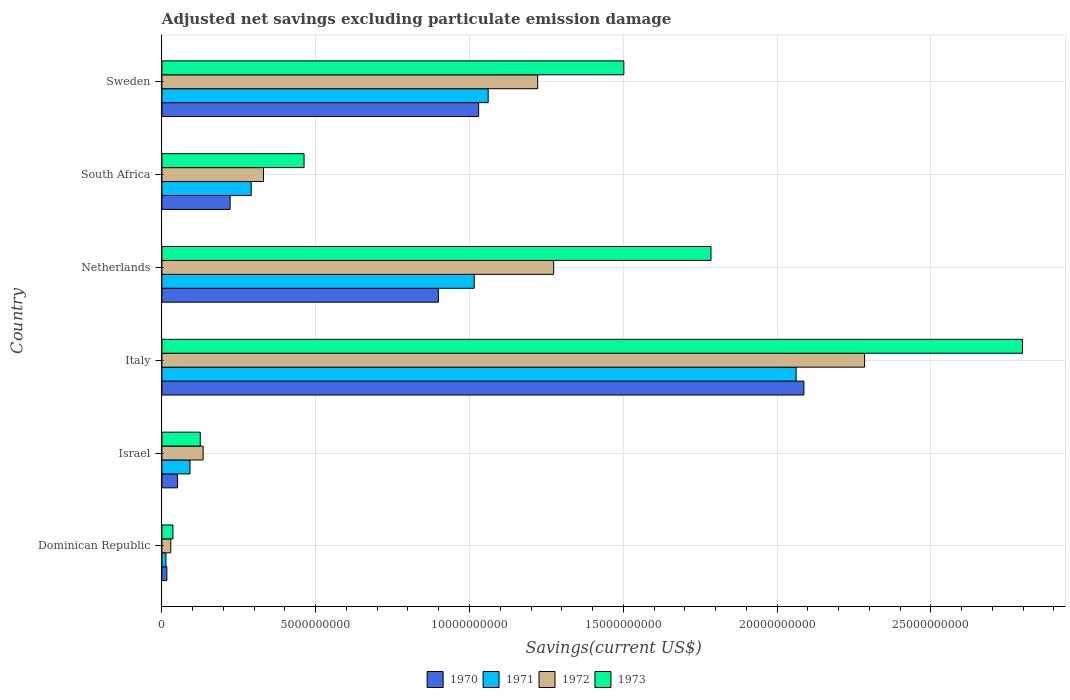Are the number of bars per tick equal to the number of legend labels?
Make the answer very short. Yes. What is the label of the 5th group of bars from the top?
Offer a terse response. Israel. What is the adjusted net savings in 1971 in Italy?
Provide a short and direct response. 2.06e+1. Across all countries, what is the maximum adjusted net savings in 1971?
Make the answer very short. 2.06e+1. Across all countries, what is the minimum adjusted net savings in 1973?
Make the answer very short. 3.58e+08. In which country was the adjusted net savings in 1973 maximum?
Give a very brief answer. Italy. In which country was the adjusted net savings in 1970 minimum?
Make the answer very short. Dominican Republic. What is the total adjusted net savings in 1973 in the graph?
Your response must be concise. 6.71e+1. What is the difference between the adjusted net savings in 1971 in Italy and that in South Africa?
Ensure brevity in your answer.  1.77e+1. What is the difference between the adjusted net savings in 1970 in Italy and the adjusted net savings in 1973 in Israel?
Keep it short and to the point. 1.96e+1. What is the average adjusted net savings in 1970 per country?
Offer a very short reply. 7.17e+09. What is the difference between the adjusted net savings in 1972 and adjusted net savings in 1971 in Sweden?
Ensure brevity in your answer.  1.61e+09. In how many countries, is the adjusted net savings in 1970 greater than 14000000000 US$?
Your answer should be very brief. 1. What is the ratio of the adjusted net savings in 1971 in Netherlands to that in Sweden?
Provide a succinct answer. 0.96. Is the difference between the adjusted net savings in 1972 in Dominican Republic and Israel greater than the difference between the adjusted net savings in 1971 in Dominican Republic and Israel?
Your answer should be very brief. No. What is the difference between the highest and the second highest adjusted net savings in 1970?
Offer a very short reply. 1.06e+1. What is the difference between the highest and the lowest adjusted net savings in 1970?
Keep it short and to the point. 2.07e+1. What does the 2nd bar from the bottom in Israel represents?
Keep it short and to the point. 1971. What is the difference between two consecutive major ticks on the X-axis?
Offer a very short reply. 5.00e+09. Where does the legend appear in the graph?
Offer a very short reply. Bottom center. How many legend labels are there?
Provide a short and direct response. 4. What is the title of the graph?
Offer a terse response. Adjusted net savings excluding particulate emission damage. What is the label or title of the X-axis?
Provide a short and direct response. Savings(current US$). What is the Savings(current US$) of 1970 in Dominican Republic?
Keep it short and to the point. 1.61e+08. What is the Savings(current US$) in 1971 in Dominican Republic?
Ensure brevity in your answer.  1.32e+08. What is the Savings(current US$) in 1972 in Dominican Republic?
Your response must be concise. 2.89e+08. What is the Savings(current US$) of 1973 in Dominican Republic?
Offer a very short reply. 3.58e+08. What is the Savings(current US$) in 1970 in Israel?
Your response must be concise. 5.08e+08. What is the Savings(current US$) of 1971 in Israel?
Provide a succinct answer. 9.14e+08. What is the Savings(current US$) in 1972 in Israel?
Your answer should be compact. 1.34e+09. What is the Savings(current US$) of 1973 in Israel?
Give a very brief answer. 1.25e+09. What is the Savings(current US$) in 1970 in Italy?
Offer a terse response. 2.09e+1. What is the Savings(current US$) of 1971 in Italy?
Keep it short and to the point. 2.06e+1. What is the Savings(current US$) of 1972 in Italy?
Provide a short and direct response. 2.28e+1. What is the Savings(current US$) in 1973 in Italy?
Provide a succinct answer. 2.80e+1. What is the Savings(current US$) of 1970 in Netherlands?
Provide a succinct answer. 8.99e+09. What is the Savings(current US$) of 1971 in Netherlands?
Offer a terse response. 1.02e+1. What is the Savings(current US$) in 1972 in Netherlands?
Provide a short and direct response. 1.27e+1. What is the Savings(current US$) in 1973 in Netherlands?
Ensure brevity in your answer.  1.79e+1. What is the Savings(current US$) in 1970 in South Africa?
Give a very brief answer. 2.22e+09. What is the Savings(current US$) of 1971 in South Africa?
Keep it short and to the point. 2.90e+09. What is the Savings(current US$) in 1972 in South Africa?
Offer a terse response. 3.30e+09. What is the Savings(current US$) of 1973 in South Africa?
Ensure brevity in your answer.  4.62e+09. What is the Savings(current US$) in 1970 in Sweden?
Make the answer very short. 1.03e+1. What is the Savings(current US$) in 1971 in Sweden?
Give a very brief answer. 1.06e+1. What is the Savings(current US$) in 1972 in Sweden?
Ensure brevity in your answer.  1.22e+1. What is the Savings(current US$) in 1973 in Sweden?
Your answer should be compact. 1.50e+1. Across all countries, what is the maximum Savings(current US$) in 1970?
Offer a very short reply. 2.09e+1. Across all countries, what is the maximum Savings(current US$) of 1971?
Make the answer very short. 2.06e+1. Across all countries, what is the maximum Savings(current US$) in 1972?
Your response must be concise. 2.28e+1. Across all countries, what is the maximum Savings(current US$) of 1973?
Keep it short and to the point. 2.80e+1. Across all countries, what is the minimum Savings(current US$) in 1970?
Your response must be concise. 1.61e+08. Across all countries, what is the minimum Savings(current US$) of 1971?
Provide a short and direct response. 1.32e+08. Across all countries, what is the minimum Savings(current US$) in 1972?
Make the answer very short. 2.89e+08. Across all countries, what is the minimum Savings(current US$) in 1973?
Your response must be concise. 3.58e+08. What is the total Savings(current US$) in 1970 in the graph?
Your response must be concise. 4.30e+1. What is the total Savings(current US$) in 1971 in the graph?
Your answer should be compact. 4.53e+1. What is the total Savings(current US$) of 1972 in the graph?
Your answer should be compact. 5.27e+1. What is the total Savings(current US$) in 1973 in the graph?
Provide a short and direct response. 6.71e+1. What is the difference between the Savings(current US$) of 1970 in Dominican Republic and that in Israel?
Offer a very short reply. -3.47e+08. What is the difference between the Savings(current US$) in 1971 in Dominican Republic and that in Israel?
Your response must be concise. -7.83e+08. What is the difference between the Savings(current US$) of 1972 in Dominican Republic and that in Israel?
Offer a terse response. -1.05e+09. What is the difference between the Savings(current US$) in 1973 in Dominican Republic and that in Israel?
Keep it short and to the point. -8.89e+08. What is the difference between the Savings(current US$) in 1970 in Dominican Republic and that in Italy?
Your response must be concise. -2.07e+1. What is the difference between the Savings(current US$) in 1971 in Dominican Republic and that in Italy?
Your response must be concise. -2.05e+1. What is the difference between the Savings(current US$) of 1972 in Dominican Republic and that in Italy?
Ensure brevity in your answer.  -2.26e+1. What is the difference between the Savings(current US$) in 1973 in Dominican Republic and that in Italy?
Make the answer very short. -2.76e+1. What is the difference between the Savings(current US$) of 1970 in Dominican Republic and that in Netherlands?
Make the answer very short. -8.83e+09. What is the difference between the Savings(current US$) in 1971 in Dominican Republic and that in Netherlands?
Ensure brevity in your answer.  -1.00e+1. What is the difference between the Savings(current US$) of 1972 in Dominican Republic and that in Netherlands?
Your response must be concise. -1.24e+1. What is the difference between the Savings(current US$) of 1973 in Dominican Republic and that in Netherlands?
Ensure brevity in your answer.  -1.75e+1. What is the difference between the Savings(current US$) of 1970 in Dominican Republic and that in South Africa?
Offer a terse response. -2.06e+09. What is the difference between the Savings(current US$) of 1971 in Dominican Republic and that in South Africa?
Provide a short and direct response. -2.77e+09. What is the difference between the Savings(current US$) of 1972 in Dominican Republic and that in South Africa?
Provide a succinct answer. -3.01e+09. What is the difference between the Savings(current US$) in 1973 in Dominican Republic and that in South Africa?
Your response must be concise. -4.26e+09. What is the difference between the Savings(current US$) in 1970 in Dominican Republic and that in Sweden?
Make the answer very short. -1.01e+1. What is the difference between the Savings(current US$) of 1971 in Dominican Republic and that in Sweden?
Provide a succinct answer. -1.05e+1. What is the difference between the Savings(current US$) of 1972 in Dominican Republic and that in Sweden?
Provide a succinct answer. -1.19e+1. What is the difference between the Savings(current US$) of 1973 in Dominican Republic and that in Sweden?
Ensure brevity in your answer.  -1.47e+1. What is the difference between the Savings(current US$) in 1970 in Israel and that in Italy?
Your answer should be very brief. -2.04e+1. What is the difference between the Savings(current US$) of 1971 in Israel and that in Italy?
Offer a very short reply. -1.97e+1. What is the difference between the Savings(current US$) in 1972 in Israel and that in Italy?
Offer a terse response. -2.15e+1. What is the difference between the Savings(current US$) of 1973 in Israel and that in Italy?
Your answer should be compact. -2.67e+1. What is the difference between the Savings(current US$) of 1970 in Israel and that in Netherlands?
Give a very brief answer. -8.48e+09. What is the difference between the Savings(current US$) in 1971 in Israel and that in Netherlands?
Make the answer very short. -9.24e+09. What is the difference between the Savings(current US$) in 1972 in Israel and that in Netherlands?
Your response must be concise. -1.14e+1. What is the difference between the Savings(current US$) in 1973 in Israel and that in Netherlands?
Your answer should be very brief. -1.66e+1. What is the difference between the Savings(current US$) in 1970 in Israel and that in South Africa?
Keep it short and to the point. -1.71e+09. What is the difference between the Savings(current US$) of 1971 in Israel and that in South Africa?
Make the answer very short. -1.99e+09. What is the difference between the Savings(current US$) of 1972 in Israel and that in South Africa?
Keep it short and to the point. -1.96e+09. What is the difference between the Savings(current US$) in 1973 in Israel and that in South Africa?
Ensure brevity in your answer.  -3.38e+09. What is the difference between the Savings(current US$) in 1970 in Israel and that in Sweden?
Your response must be concise. -9.79e+09. What is the difference between the Savings(current US$) of 1971 in Israel and that in Sweden?
Make the answer very short. -9.69e+09. What is the difference between the Savings(current US$) of 1972 in Israel and that in Sweden?
Provide a succinct answer. -1.09e+1. What is the difference between the Savings(current US$) in 1973 in Israel and that in Sweden?
Your response must be concise. -1.38e+1. What is the difference between the Savings(current US$) of 1970 in Italy and that in Netherlands?
Provide a succinct answer. 1.19e+1. What is the difference between the Savings(current US$) in 1971 in Italy and that in Netherlands?
Ensure brevity in your answer.  1.05e+1. What is the difference between the Savings(current US$) of 1972 in Italy and that in Netherlands?
Provide a succinct answer. 1.01e+1. What is the difference between the Savings(current US$) of 1973 in Italy and that in Netherlands?
Make the answer very short. 1.01e+1. What is the difference between the Savings(current US$) of 1970 in Italy and that in South Africa?
Give a very brief answer. 1.87e+1. What is the difference between the Savings(current US$) in 1971 in Italy and that in South Africa?
Offer a terse response. 1.77e+1. What is the difference between the Savings(current US$) in 1972 in Italy and that in South Africa?
Your answer should be very brief. 1.95e+1. What is the difference between the Savings(current US$) in 1973 in Italy and that in South Africa?
Make the answer very short. 2.34e+1. What is the difference between the Savings(current US$) of 1970 in Italy and that in Sweden?
Ensure brevity in your answer.  1.06e+1. What is the difference between the Savings(current US$) in 1971 in Italy and that in Sweden?
Provide a succinct answer. 1.00e+1. What is the difference between the Savings(current US$) in 1972 in Italy and that in Sweden?
Ensure brevity in your answer.  1.06e+1. What is the difference between the Savings(current US$) in 1973 in Italy and that in Sweden?
Provide a short and direct response. 1.30e+1. What is the difference between the Savings(current US$) in 1970 in Netherlands and that in South Africa?
Make the answer very short. 6.77e+09. What is the difference between the Savings(current US$) in 1971 in Netherlands and that in South Africa?
Your response must be concise. 7.25e+09. What is the difference between the Savings(current US$) in 1972 in Netherlands and that in South Africa?
Make the answer very short. 9.43e+09. What is the difference between the Savings(current US$) of 1973 in Netherlands and that in South Africa?
Your answer should be compact. 1.32e+1. What is the difference between the Savings(current US$) of 1970 in Netherlands and that in Sweden?
Your answer should be very brief. -1.31e+09. What is the difference between the Savings(current US$) of 1971 in Netherlands and that in Sweden?
Ensure brevity in your answer.  -4.54e+08. What is the difference between the Savings(current US$) in 1972 in Netherlands and that in Sweden?
Keep it short and to the point. 5.20e+08. What is the difference between the Savings(current US$) in 1973 in Netherlands and that in Sweden?
Keep it short and to the point. 2.83e+09. What is the difference between the Savings(current US$) of 1970 in South Africa and that in Sweden?
Your answer should be very brief. -8.08e+09. What is the difference between the Savings(current US$) of 1971 in South Africa and that in Sweden?
Offer a very short reply. -7.70e+09. What is the difference between the Savings(current US$) of 1972 in South Africa and that in Sweden?
Your answer should be compact. -8.91e+09. What is the difference between the Savings(current US$) in 1973 in South Africa and that in Sweden?
Offer a terse response. -1.04e+1. What is the difference between the Savings(current US$) in 1970 in Dominican Republic and the Savings(current US$) in 1971 in Israel?
Provide a succinct answer. -7.53e+08. What is the difference between the Savings(current US$) of 1970 in Dominican Republic and the Savings(current US$) of 1972 in Israel?
Your answer should be very brief. -1.18e+09. What is the difference between the Savings(current US$) in 1970 in Dominican Republic and the Savings(current US$) in 1973 in Israel?
Keep it short and to the point. -1.09e+09. What is the difference between the Savings(current US$) in 1971 in Dominican Republic and the Savings(current US$) in 1972 in Israel?
Provide a short and direct response. -1.21e+09. What is the difference between the Savings(current US$) of 1971 in Dominican Republic and the Savings(current US$) of 1973 in Israel?
Give a very brief answer. -1.12e+09. What is the difference between the Savings(current US$) of 1972 in Dominican Republic and the Savings(current US$) of 1973 in Israel?
Give a very brief answer. -9.58e+08. What is the difference between the Savings(current US$) of 1970 in Dominican Republic and the Savings(current US$) of 1971 in Italy?
Provide a succinct answer. -2.05e+1. What is the difference between the Savings(current US$) in 1970 in Dominican Republic and the Savings(current US$) in 1972 in Italy?
Your response must be concise. -2.27e+1. What is the difference between the Savings(current US$) of 1970 in Dominican Republic and the Savings(current US$) of 1973 in Italy?
Offer a very short reply. -2.78e+1. What is the difference between the Savings(current US$) in 1971 in Dominican Republic and the Savings(current US$) in 1972 in Italy?
Offer a terse response. -2.27e+1. What is the difference between the Savings(current US$) of 1971 in Dominican Republic and the Savings(current US$) of 1973 in Italy?
Keep it short and to the point. -2.78e+1. What is the difference between the Savings(current US$) of 1972 in Dominican Republic and the Savings(current US$) of 1973 in Italy?
Offer a terse response. -2.77e+1. What is the difference between the Savings(current US$) of 1970 in Dominican Republic and the Savings(current US$) of 1971 in Netherlands?
Offer a terse response. -9.99e+09. What is the difference between the Savings(current US$) of 1970 in Dominican Republic and the Savings(current US$) of 1972 in Netherlands?
Provide a short and direct response. -1.26e+1. What is the difference between the Savings(current US$) in 1970 in Dominican Republic and the Savings(current US$) in 1973 in Netherlands?
Make the answer very short. -1.77e+1. What is the difference between the Savings(current US$) in 1971 in Dominican Republic and the Savings(current US$) in 1972 in Netherlands?
Give a very brief answer. -1.26e+1. What is the difference between the Savings(current US$) in 1971 in Dominican Republic and the Savings(current US$) in 1973 in Netherlands?
Your answer should be compact. -1.77e+1. What is the difference between the Savings(current US$) in 1972 in Dominican Republic and the Savings(current US$) in 1973 in Netherlands?
Keep it short and to the point. -1.76e+1. What is the difference between the Savings(current US$) in 1970 in Dominican Republic and the Savings(current US$) in 1971 in South Africa?
Offer a very short reply. -2.74e+09. What is the difference between the Savings(current US$) of 1970 in Dominican Republic and the Savings(current US$) of 1972 in South Africa?
Provide a short and direct response. -3.14e+09. What is the difference between the Savings(current US$) of 1970 in Dominican Republic and the Savings(current US$) of 1973 in South Africa?
Keep it short and to the point. -4.46e+09. What is the difference between the Savings(current US$) of 1971 in Dominican Republic and the Savings(current US$) of 1972 in South Africa?
Ensure brevity in your answer.  -3.17e+09. What is the difference between the Savings(current US$) of 1971 in Dominican Republic and the Savings(current US$) of 1973 in South Africa?
Provide a succinct answer. -4.49e+09. What is the difference between the Savings(current US$) of 1972 in Dominican Republic and the Savings(current US$) of 1973 in South Africa?
Offer a terse response. -4.33e+09. What is the difference between the Savings(current US$) in 1970 in Dominican Republic and the Savings(current US$) in 1971 in Sweden?
Ensure brevity in your answer.  -1.04e+1. What is the difference between the Savings(current US$) of 1970 in Dominican Republic and the Savings(current US$) of 1972 in Sweden?
Provide a short and direct response. -1.21e+1. What is the difference between the Savings(current US$) of 1970 in Dominican Republic and the Savings(current US$) of 1973 in Sweden?
Your response must be concise. -1.49e+1. What is the difference between the Savings(current US$) of 1971 in Dominican Republic and the Savings(current US$) of 1972 in Sweden?
Make the answer very short. -1.21e+1. What is the difference between the Savings(current US$) in 1971 in Dominican Republic and the Savings(current US$) in 1973 in Sweden?
Offer a terse response. -1.49e+1. What is the difference between the Savings(current US$) in 1972 in Dominican Republic and the Savings(current US$) in 1973 in Sweden?
Ensure brevity in your answer.  -1.47e+1. What is the difference between the Savings(current US$) in 1970 in Israel and the Savings(current US$) in 1971 in Italy?
Make the answer very short. -2.01e+1. What is the difference between the Savings(current US$) of 1970 in Israel and the Savings(current US$) of 1972 in Italy?
Ensure brevity in your answer.  -2.23e+1. What is the difference between the Savings(current US$) in 1970 in Israel and the Savings(current US$) in 1973 in Italy?
Your answer should be compact. -2.75e+1. What is the difference between the Savings(current US$) of 1971 in Israel and the Savings(current US$) of 1972 in Italy?
Offer a very short reply. -2.19e+1. What is the difference between the Savings(current US$) of 1971 in Israel and the Savings(current US$) of 1973 in Italy?
Provide a short and direct response. -2.71e+1. What is the difference between the Savings(current US$) of 1972 in Israel and the Savings(current US$) of 1973 in Italy?
Give a very brief answer. -2.66e+1. What is the difference between the Savings(current US$) of 1970 in Israel and the Savings(current US$) of 1971 in Netherlands?
Your answer should be very brief. -9.65e+09. What is the difference between the Savings(current US$) of 1970 in Israel and the Savings(current US$) of 1972 in Netherlands?
Offer a terse response. -1.22e+1. What is the difference between the Savings(current US$) in 1970 in Israel and the Savings(current US$) in 1973 in Netherlands?
Keep it short and to the point. -1.73e+1. What is the difference between the Savings(current US$) in 1971 in Israel and the Savings(current US$) in 1972 in Netherlands?
Your response must be concise. -1.18e+1. What is the difference between the Savings(current US$) in 1971 in Israel and the Savings(current US$) in 1973 in Netherlands?
Offer a terse response. -1.69e+1. What is the difference between the Savings(current US$) of 1972 in Israel and the Savings(current US$) of 1973 in Netherlands?
Your answer should be compact. -1.65e+1. What is the difference between the Savings(current US$) in 1970 in Israel and the Savings(current US$) in 1971 in South Africa?
Your answer should be very brief. -2.39e+09. What is the difference between the Savings(current US$) of 1970 in Israel and the Savings(current US$) of 1972 in South Africa?
Your answer should be compact. -2.79e+09. What is the difference between the Savings(current US$) in 1970 in Israel and the Savings(current US$) in 1973 in South Africa?
Provide a succinct answer. -4.11e+09. What is the difference between the Savings(current US$) in 1971 in Israel and the Savings(current US$) in 1972 in South Africa?
Make the answer very short. -2.39e+09. What is the difference between the Savings(current US$) of 1971 in Israel and the Savings(current US$) of 1973 in South Africa?
Your answer should be very brief. -3.71e+09. What is the difference between the Savings(current US$) of 1972 in Israel and the Savings(current US$) of 1973 in South Africa?
Give a very brief answer. -3.28e+09. What is the difference between the Savings(current US$) in 1970 in Israel and the Savings(current US$) in 1971 in Sweden?
Keep it short and to the point. -1.01e+1. What is the difference between the Savings(current US$) in 1970 in Israel and the Savings(current US$) in 1972 in Sweden?
Make the answer very short. -1.17e+1. What is the difference between the Savings(current US$) of 1970 in Israel and the Savings(current US$) of 1973 in Sweden?
Give a very brief answer. -1.45e+1. What is the difference between the Savings(current US$) in 1971 in Israel and the Savings(current US$) in 1972 in Sweden?
Provide a succinct answer. -1.13e+1. What is the difference between the Savings(current US$) of 1971 in Israel and the Savings(current US$) of 1973 in Sweden?
Offer a very short reply. -1.41e+1. What is the difference between the Savings(current US$) in 1972 in Israel and the Savings(current US$) in 1973 in Sweden?
Give a very brief answer. -1.37e+1. What is the difference between the Savings(current US$) of 1970 in Italy and the Savings(current US$) of 1971 in Netherlands?
Offer a terse response. 1.07e+1. What is the difference between the Savings(current US$) in 1970 in Italy and the Savings(current US$) in 1972 in Netherlands?
Provide a short and direct response. 8.14e+09. What is the difference between the Savings(current US$) in 1970 in Italy and the Savings(current US$) in 1973 in Netherlands?
Keep it short and to the point. 3.02e+09. What is the difference between the Savings(current US$) in 1971 in Italy and the Savings(current US$) in 1972 in Netherlands?
Keep it short and to the point. 7.88e+09. What is the difference between the Savings(current US$) of 1971 in Italy and the Savings(current US$) of 1973 in Netherlands?
Your answer should be compact. 2.77e+09. What is the difference between the Savings(current US$) in 1972 in Italy and the Savings(current US$) in 1973 in Netherlands?
Your answer should be compact. 4.99e+09. What is the difference between the Savings(current US$) of 1970 in Italy and the Savings(current US$) of 1971 in South Africa?
Make the answer very short. 1.80e+1. What is the difference between the Savings(current US$) in 1970 in Italy and the Savings(current US$) in 1972 in South Africa?
Give a very brief answer. 1.76e+1. What is the difference between the Savings(current US$) of 1970 in Italy and the Savings(current US$) of 1973 in South Africa?
Offer a very short reply. 1.62e+1. What is the difference between the Savings(current US$) of 1971 in Italy and the Savings(current US$) of 1972 in South Africa?
Your response must be concise. 1.73e+1. What is the difference between the Savings(current US$) in 1971 in Italy and the Savings(current US$) in 1973 in South Africa?
Ensure brevity in your answer.  1.60e+1. What is the difference between the Savings(current US$) of 1972 in Italy and the Savings(current US$) of 1973 in South Africa?
Keep it short and to the point. 1.82e+1. What is the difference between the Savings(current US$) of 1970 in Italy and the Savings(current US$) of 1971 in Sweden?
Your response must be concise. 1.03e+1. What is the difference between the Savings(current US$) of 1970 in Italy and the Savings(current US$) of 1972 in Sweden?
Your response must be concise. 8.66e+09. What is the difference between the Savings(current US$) of 1970 in Italy and the Savings(current US$) of 1973 in Sweden?
Offer a terse response. 5.85e+09. What is the difference between the Savings(current US$) in 1971 in Italy and the Savings(current US$) in 1972 in Sweden?
Provide a short and direct response. 8.40e+09. What is the difference between the Savings(current US$) in 1971 in Italy and the Savings(current US$) in 1973 in Sweden?
Ensure brevity in your answer.  5.60e+09. What is the difference between the Savings(current US$) of 1972 in Italy and the Savings(current US$) of 1973 in Sweden?
Provide a short and direct response. 7.83e+09. What is the difference between the Savings(current US$) in 1970 in Netherlands and the Savings(current US$) in 1971 in South Africa?
Offer a terse response. 6.09e+09. What is the difference between the Savings(current US$) in 1970 in Netherlands and the Savings(current US$) in 1972 in South Africa?
Offer a terse response. 5.69e+09. What is the difference between the Savings(current US$) in 1970 in Netherlands and the Savings(current US$) in 1973 in South Africa?
Your response must be concise. 4.37e+09. What is the difference between the Savings(current US$) in 1971 in Netherlands and the Savings(current US$) in 1972 in South Africa?
Give a very brief answer. 6.85e+09. What is the difference between the Savings(current US$) of 1971 in Netherlands and the Savings(current US$) of 1973 in South Africa?
Offer a very short reply. 5.53e+09. What is the difference between the Savings(current US$) of 1972 in Netherlands and the Savings(current US$) of 1973 in South Africa?
Ensure brevity in your answer.  8.11e+09. What is the difference between the Savings(current US$) in 1970 in Netherlands and the Savings(current US$) in 1971 in Sweden?
Your response must be concise. -1.62e+09. What is the difference between the Savings(current US$) of 1970 in Netherlands and the Savings(current US$) of 1972 in Sweden?
Offer a terse response. -3.23e+09. What is the difference between the Savings(current US$) in 1970 in Netherlands and the Savings(current US$) in 1973 in Sweden?
Your answer should be compact. -6.03e+09. What is the difference between the Savings(current US$) in 1971 in Netherlands and the Savings(current US$) in 1972 in Sweden?
Ensure brevity in your answer.  -2.06e+09. What is the difference between the Savings(current US$) in 1971 in Netherlands and the Savings(current US$) in 1973 in Sweden?
Your answer should be very brief. -4.86e+09. What is the difference between the Savings(current US$) of 1972 in Netherlands and the Savings(current US$) of 1973 in Sweden?
Provide a succinct answer. -2.28e+09. What is the difference between the Savings(current US$) of 1970 in South Africa and the Savings(current US$) of 1971 in Sweden?
Make the answer very short. -8.39e+09. What is the difference between the Savings(current US$) in 1970 in South Africa and the Savings(current US$) in 1972 in Sweden?
Provide a short and direct response. -1.00e+1. What is the difference between the Savings(current US$) in 1970 in South Africa and the Savings(current US$) in 1973 in Sweden?
Keep it short and to the point. -1.28e+1. What is the difference between the Savings(current US$) of 1971 in South Africa and the Savings(current US$) of 1972 in Sweden?
Offer a very short reply. -9.31e+09. What is the difference between the Savings(current US$) of 1971 in South Africa and the Savings(current US$) of 1973 in Sweden?
Your answer should be very brief. -1.21e+1. What is the difference between the Savings(current US$) in 1972 in South Africa and the Savings(current US$) in 1973 in Sweden?
Your response must be concise. -1.17e+1. What is the average Savings(current US$) of 1970 per country?
Provide a short and direct response. 7.17e+09. What is the average Savings(current US$) in 1971 per country?
Ensure brevity in your answer.  7.55e+09. What is the average Savings(current US$) of 1972 per country?
Your answer should be very brief. 8.79e+09. What is the average Savings(current US$) in 1973 per country?
Provide a short and direct response. 1.12e+1. What is the difference between the Savings(current US$) in 1970 and Savings(current US$) in 1971 in Dominican Republic?
Provide a succinct answer. 2.96e+07. What is the difference between the Savings(current US$) of 1970 and Savings(current US$) of 1972 in Dominican Republic?
Provide a succinct answer. -1.28e+08. What is the difference between the Savings(current US$) in 1970 and Savings(current US$) in 1973 in Dominican Republic?
Provide a succinct answer. -1.97e+08. What is the difference between the Savings(current US$) in 1971 and Savings(current US$) in 1972 in Dominican Republic?
Your response must be concise. -1.57e+08. What is the difference between the Savings(current US$) of 1971 and Savings(current US$) of 1973 in Dominican Republic?
Provide a short and direct response. -2.27e+08. What is the difference between the Savings(current US$) of 1972 and Savings(current US$) of 1973 in Dominican Republic?
Keep it short and to the point. -6.95e+07. What is the difference between the Savings(current US$) in 1970 and Savings(current US$) in 1971 in Israel?
Your response must be concise. -4.06e+08. What is the difference between the Savings(current US$) of 1970 and Savings(current US$) of 1972 in Israel?
Provide a succinct answer. -8.33e+08. What is the difference between the Savings(current US$) of 1970 and Savings(current US$) of 1973 in Israel?
Your answer should be compact. -7.39e+08. What is the difference between the Savings(current US$) in 1971 and Savings(current US$) in 1972 in Israel?
Your response must be concise. -4.27e+08. What is the difference between the Savings(current US$) in 1971 and Savings(current US$) in 1973 in Israel?
Provide a succinct answer. -3.33e+08. What is the difference between the Savings(current US$) in 1972 and Savings(current US$) in 1973 in Israel?
Give a very brief answer. 9.40e+07. What is the difference between the Savings(current US$) in 1970 and Savings(current US$) in 1971 in Italy?
Keep it short and to the point. 2.53e+08. What is the difference between the Savings(current US$) of 1970 and Savings(current US$) of 1972 in Italy?
Give a very brief answer. -1.97e+09. What is the difference between the Savings(current US$) in 1970 and Savings(current US$) in 1973 in Italy?
Offer a terse response. -7.11e+09. What is the difference between the Savings(current US$) of 1971 and Savings(current US$) of 1972 in Italy?
Ensure brevity in your answer.  -2.23e+09. What is the difference between the Savings(current US$) in 1971 and Savings(current US$) in 1973 in Italy?
Offer a very short reply. -7.36e+09. What is the difference between the Savings(current US$) of 1972 and Savings(current US$) of 1973 in Italy?
Provide a short and direct response. -5.13e+09. What is the difference between the Savings(current US$) of 1970 and Savings(current US$) of 1971 in Netherlands?
Provide a succinct answer. -1.17e+09. What is the difference between the Savings(current US$) in 1970 and Savings(current US$) in 1972 in Netherlands?
Give a very brief answer. -3.75e+09. What is the difference between the Savings(current US$) in 1970 and Savings(current US$) in 1973 in Netherlands?
Provide a short and direct response. -8.86e+09. What is the difference between the Savings(current US$) in 1971 and Savings(current US$) in 1972 in Netherlands?
Your answer should be very brief. -2.58e+09. What is the difference between the Savings(current US$) of 1971 and Savings(current US$) of 1973 in Netherlands?
Offer a terse response. -7.70e+09. What is the difference between the Savings(current US$) of 1972 and Savings(current US$) of 1973 in Netherlands?
Your response must be concise. -5.11e+09. What is the difference between the Savings(current US$) in 1970 and Savings(current US$) in 1971 in South Africa?
Your answer should be compact. -6.85e+08. What is the difference between the Savings(current US$) in 1970 and Savings(current US$) in 1972 in South Africa?
Keep it short and to the point. -1.08e+09. What is the difference between the Savings(current US$) in 1970 and Savings(current US$) in 1973 in South Africa?
Your response must be concise. -2.40e+09. What is the difference between the Savings(current US$) of 1971 and Savings(current US$) of 1972 in South Africa?
Your response must be concise. -4.00e+08. What is the difference between the Savings(current US$) of 1971 and Savings(current US$) of 1973 in South Africa?
Your response must be concise. -1.72e+09. What is the difference between the Savings(current US$) in 1972 and Savings(current US$) in 1973 in South Africa?
Offer a very short reply. -1.32e+09. What is the difference between the Savings(current US$) in 1970 and Savings(current US$) in 1971 in Sweden?
Ensure brevity in your answer.  -3.10e+08. What is the difference between the Savings(current US$) of 1970 and Savings(current US$) of 1972 in Sweden?
Keep it short and to the point. -1.92e+09. What is the difference between the Savings(current US$) in 1970 and Savings(current US$) in 1973 in Sweden?
Make the answer very short. -4.72e+09. What is the difference between the Savings(current US$) of 1971 and Savings(current US$) of 1972 in Sweden?
Your answer should be compact. -1.61e+09. What is the difference between the Savings(current US$) in 1971 and Savings(current US$) in 1973 in Sweden?
Offer a very short reply. -4.41e+09. What is the difference between the Savings(current US$) in 1972 and Savings(current US$) in 1973 in Sweden?
Your answer should be very brief. -2.80e+09. What is the ratio of the Savings(current US$) of 1970 in Dominican Republic to that in Israel?
Your answer should be compact. 0.32. What is the ratio of the Savings(current US$) of 1971 in Dominican Republic to that in Israel?
Provide a short and direct response. 0.14. What is the ratio of the Savings(current US$) of 1972 in Dominican Republic to that in Israel?
Your answer should be compact. 0.22. What is the ratio of the Savings(current US$) of 1973 in Dominican Republic to that in Israel?
Your answer should be compact. 0.29. What is the ratio of the Savings(current US$) of 1970 in Dominican Republic to that in Italy?
Offer a very short reply. 0.01. What is the ratio of the Savings(current US$) of 1971 in Dominican Republic to that in Italy?
Ensure brevity in your answer.  0.01. What is the ratio of the Savings(current US$) in 1972 in Dominican Republic to that in Italy?
Make the answer very short. 0.01. What is the ratio of the Savings(current US$) of 1973 in Dominican Republic to that in Italy?
Provide a short and direct response. 0.01. What is the ratio of the Savings(current US$) in 1970 in Dominican Republic to that in Netherlands?
Your answer should be compact. 0.02. What is the ratio of the Savings(current US$) in 1971 in Dominican Republic to that in Netherlands?
Offer a terse response. 0.01. What is the ratio of the Savings(current US$) of 1972 in Dominican Republic to that in Netherlands?
Ensure brevity in your answer.  0.02. What is the ratio of the Savings(current US$) in 1973 in Dominican Republic to that in Netherlands?
Your answer should be very brief. 0.02. What is the ratio of the Savings(current US$) of 1970 in Dominican Republic to that in South Africa?
Your answer should be very brief. 0.07. What is the ratio of the Savings(current US$) of 1971 in Dominican Republic to that in South Africa?
Ensure brevity in your answer.  0.05. What is the ratio of the Savings(current US$) of 1972 in Dominican Republic to that in South Africa?
Provide a short and direct response. 0.09. What is the ratio of the Savings(current US$) in 1973 in Dominican Republic to that in South Africa?
Give a very brief answer. 0.08. What is the ratio of the Savings(current US$) of 1970 in Dominican Republic to that in Sweden?
Your answer should be very brief. 0.02. What is the ratio of the Savings(current US$) of 1971 in Dominican Republic to that in Sweden?
Provide a short and direct response. 0.01. What is the ratio of the Savings(current US$) in 1972 in Dominican Republic to that in Sweden?
Give a very brief answer. 0.02. What is the ratio of the Savings(current US$) of 1973 in Dominican Republic to that in Sweden?
Your response must be concise. 0.02. What is the ratio of the Savings(current US$) in 1970 in Israel to that in Italy?
Keep it short and to the point. 0.02. What is the ratio of the Savings(current US$) of 1971 in Israel to that in Italy?
Provide a short and direct response. 0.04. What is the ratio of the Savings(current US$) of 1972 in Israel to that in Italy?
Provide a short and direct response. 0.06. What is the ratio of the Savings(current US$) in 1973 in Israel to that in Italy?
Keep it short and to the point. 0.04. What is the ratio of the Savings(current US$) in 1970 in Israel to that in Netherlands?
Provide a short and direct response. 0.06. What is the ratio of the Savings(current US$) of 1971 in Israel to that in Netherlands?
Your answer should be very brief. 0.09. What is the ratio of the Savings(current US$) in 1972 in Israel to that in Netherlands?
Your answer should be compact. 0.11. What is the ratio of the Savings(current US$) in 1973 in Israel to that in Netherlands?
Your response must be concise. 0.07. What is the ratio of the Savings(current US$) in 1970 in Israel to that in South Africa?
Make the answer very short. 0.23. What is the ratio of the Savings(current US$) in 1971 in Israel to that in South Africa?
Your answer should be compact. 0.32. What is the ratio of the Savings(current US$) in 1972 in Israel to that in South Africa?
Your answer should be very brief. 0.41. What is the ratio of the Savings(current US$) in 1973 in Israel to that in South Africa?
Make the answer very short. 0.27. What is the ratio of the Savings(current US$) in 1970 in Israel to that in Sweden?
Provide a succinct answer. 0.05. What is the ratio of the Savings(current US$) in 1971 in Israel to that in Sweden?
Provide a succinct answer. 0.09. What is the ratio of the Savings(current US$) in 1972 in Israel to that in Sweden?
Keep it short and to the point. 0.11. What is the ratio of the Savings(current US$) of 1973 in Israel to that in Sweden?
Ensure brevity in your answer.  0.08. What is the ratio of the Savings(current US$) of 1970 in Italy to that in Netherlands?
Ensure brevity in your answer.  2.32. What is the ratio of the Savings(current US$) of 1971 in Italy to that in Netherlands?
Ensure brevity in your answer.  2.03. What is the ratio of the Savings(current US$) in 1972 in Italy to that in Netherlands?
Provide a succinct answer. 1.79. What is the ratio of the Savings(current US$) of 1973 in Italy to that in Netherlands?
Keep it short and to the point. 1.57. What is the ratio of the Savings(current US$) in 1970 in Italy to that in South Africa?
Your answer should be compact. 9.41. What is the ratio of the Savings(current US$) of 1971 in Italy to that in South Africa?
Provide a short and direct response. 7.1. What is the ratio of the Savings(current US$) in 1972 in Italy to that in South Africa?
Ensure brevity in your answer.  6.92. What is the ratio of the Savings(current US$) of 1973 in Italy to that in South Africa?
Offer a very short reply. 6.05. What is the ratio of the Savings(current US$) in 1970 in Italy to that in Sweden?
Your answer should be compact. 2.03. What is the ratio of the Savings(current US$) in 1971 in Italy to that in Sweden?
Offer a terse response. 1.94. What is the ratio of the Savings(current US$) of 1972 in Italy to that in Sweden?
Provide a succinct answer. 1.87. What is the ratio of the Savings(current US$) in 1973 in Italy to that in Sweden?
Offer a very short reply. 1.86. What is the ratio of the Savings(current US$) in 1970 in Netherlands to that in South Africa?
Ensure brevity in your answer.  4.05. What is the ratio of the Savings(current US$) in 1971 in Netherlands to that in South Africa?
Offer a very short reply. 3.5. What is the ratio of the Savings(current US$) of 1972 in Netherlands to that in South Africa?
Make the answer very short. 3.86. What is the ratio of the Savings(current US$) of 1973 in Netherlands to that in South Africa?
Your response must be concise. 3.86. What is the ratio of the Savings(current US$) in 1970 in Netherlands to that in Sweden?
Offer a terse response. 0.87. What is the ratio of the Savings(current US$) in 1971 in Netherlands to that in Sweden?
Offer a very short reply. 0.96. What is the ratio of the Savings(current US$) of 1972 in Netherlands to that in Sweden?
Your answer should be compact. 1.04. What is the ratio of the Savings(current US$) in 1973 in Netherlands to that in Sweden?
Your answer should be compact. 1.19. What is the ratio of the Savings(current US$) in 1970 in South Africa to that in Sweden?
Your answer should be very brief. 0.22. What is the ratio of the Savings(current US$) in 1971 in South Africa to that in Sweden?
Make the answer very short. 0.27. What is the ratio of the Savings(current US$) of 1972 in South Africa to that in Sweden?
Give a very brief answer. 0.27. What is the ratio of the Savings(current US$) of 1973 in South Africa to that in Sweden?
Provide a short and direct response. 0.31. What is the difference between the highest and the second highest Savings(current US$) in 1970?
Keep it short and to the point. 1.06e+1. What is the difference between the highest and the second highest Savings(current US$) in 1971?
Your response must be concise. 1.00e+1. What is the difference between the highest and the second highest Savings(current US$) of 1972?
Your answer should be very brief. 1.01e+1. What is the difference between the highest and the second highest Savings(current US$) of 1973?
Your response must be concise. 1.01e+1. What is the difference between the highest and the lowest Savings(current US$) in 1970?
Ensure brevity in your answer.  2.07e+1. What is the difference between the highest and the lowest Savings(current US$) in 1971?
Offer a terse response. 2.05e+1. What is the difference between the highest and the lowest Savings(current US$) in 1972?
Your response must be concise. 2.26e+1. What is the difference between the highest and the lowest Savings(current US$) in 1973?
Provide a succinct answer. 2.76e+1. 